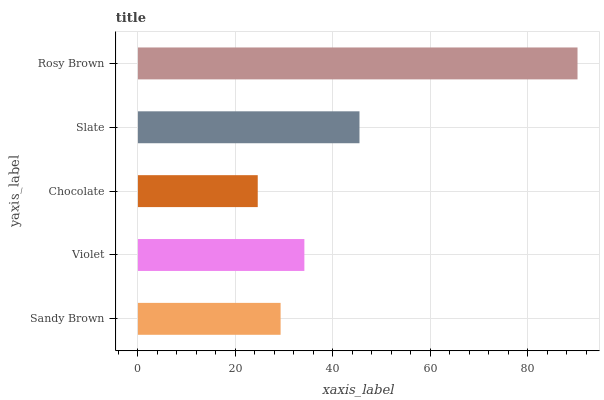Is Chocolate the minimum?
Answer yes or no. Yes. Is Rosy Brown the maximum?
Answer yes or no. Yes. Is Violet the minimum?
Answer yes or no. No. Is Violet the maximum?
Answer yes or no. No. Is Violet greater than Sandy Brown?
Answer yes or no. Yes. Is Sandy Brown less than Violet?
Answer yes or no. Yes. Is Sandy Brown greater than Violet?
Answer yes or no. No. Is Violet less than Sandy Brown?
Answer yes or no. No. Is Violet the high median?
Answer yes or no. Yes. Is Violet the low median?
Answer yes or no. Yes. Is Slate the high median?
Answer yes or no. No. Is Chocolate the low median?
Answer yes or no. No. 